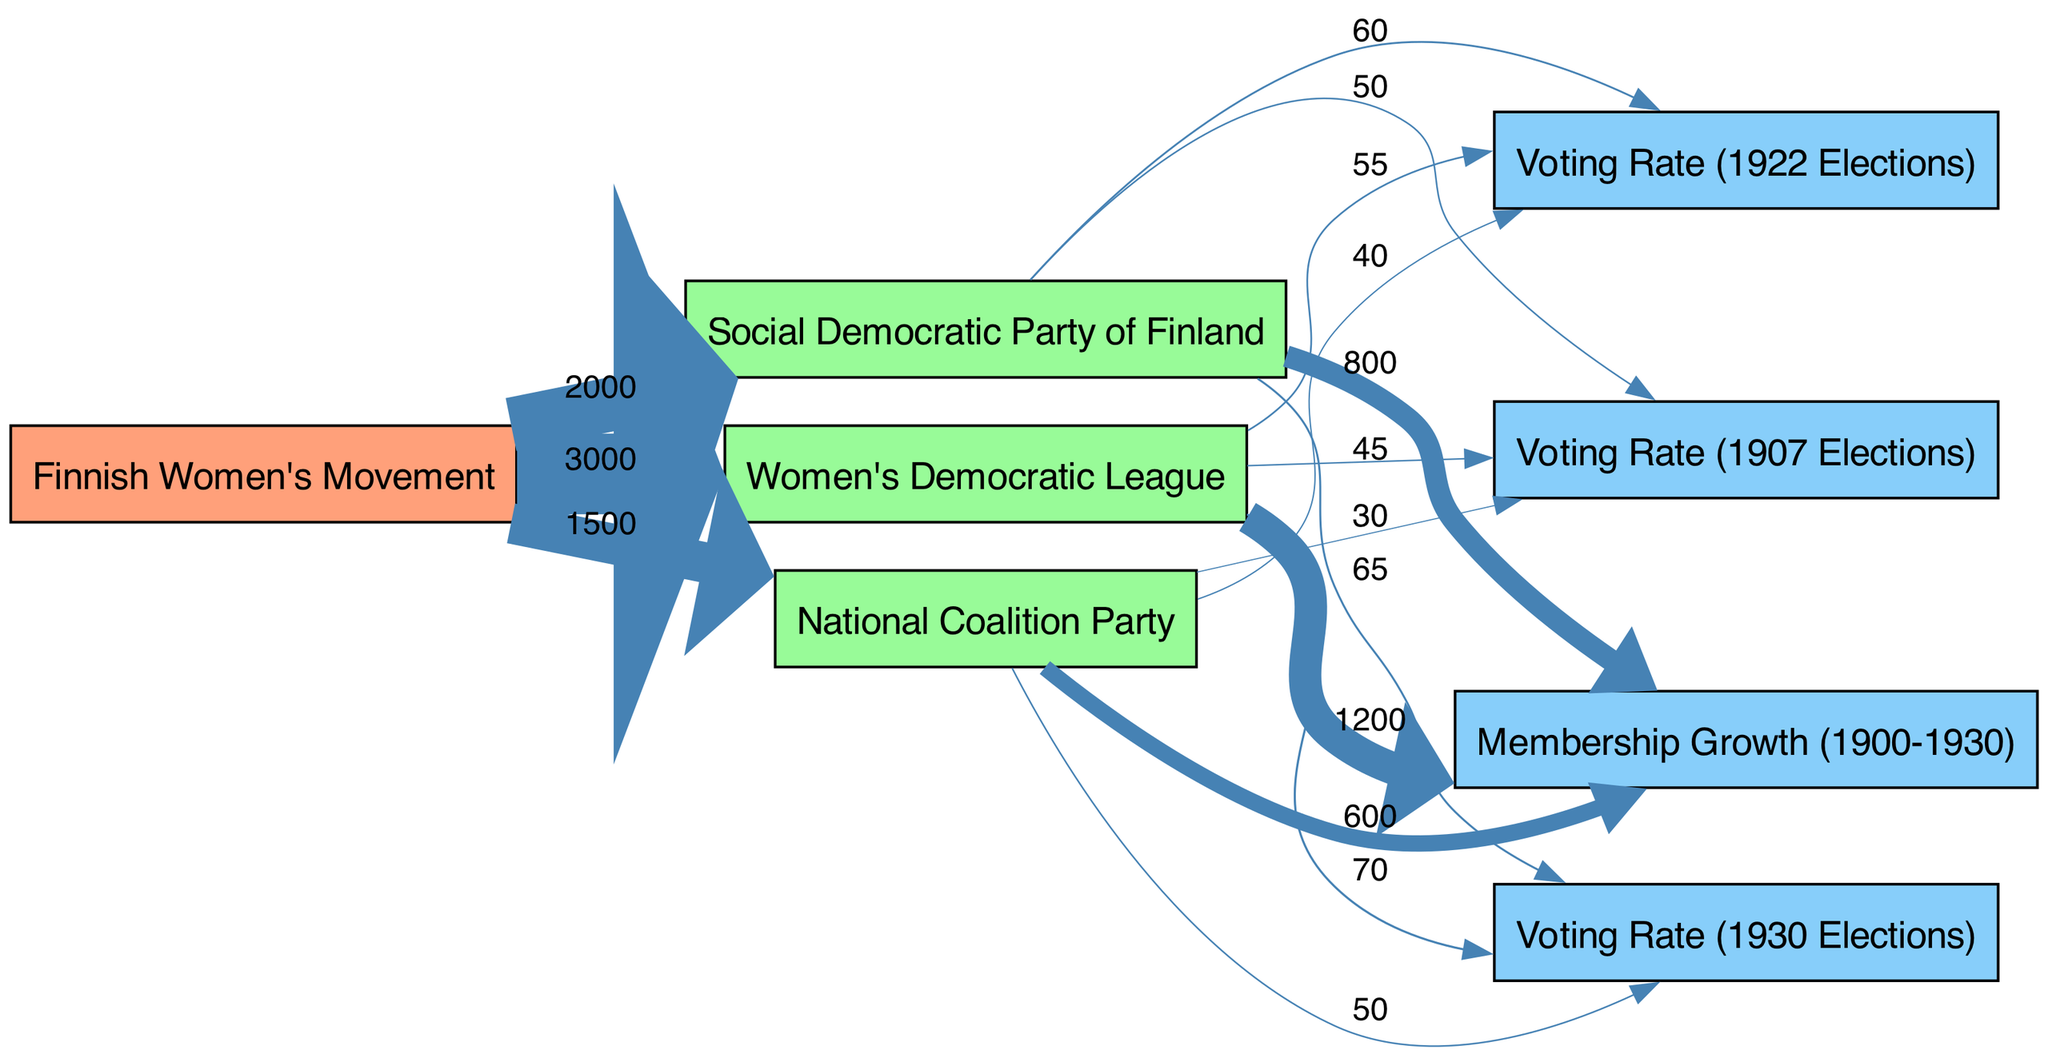What is the total membership flow to the Women's Democratic League? To find the total membership flow to the Women's Democratic League, we can observe the links stemming from "Finnish Women's Movement" to "Women's Democratic League", which shows a value of 3000 for member flow. This is the sum total for this party without further branching for membership.
Answer: 3000 What is the voting rate for the Social Democratic Party of Finland in the 1922 elections? In the section of the diagram that highlights voting trends, we find that the link from "Social Democratic Party of Finland" to "Voting Rate (1922 Elections)" specifies a value of 60. This directly provides the information requested about the voting rate in that election year for the Social Democratic Party.
Answer: 60 Which party had the lowest voting rate in the 1907 elections? By examining the voting rate values linked to each party in the 1907 elections, we note the following values: Women's Democratic League is 45, Social Democratic Party of Finland is 50, and National Coalition Party is 30. The lowest value here is that of the National Coalition Party, indicating it had the least voting rate in that year.
Answer: National Coalition Party What trends can be observed in membership growth from Women's Democratic League compared to the others? The membership growth for Women's Democratic League shows a value of 1200, Social Democratic Party of Finland has 800, and National Coalition Party has 600. Comparing these values, we can clearly see that the Women's Democratic League experienced the most membership growth from the Finnish Women's Movement over the given time period.
Answer: Women's Democratic League Which party saw the highest voting rate in the 1930 elections? In the section highlighting voting rates for the 1930 elections, we observe the linked values as follows: Women's Democratic League with 70, Social Democratic Party of Finland with 65, and National Coalition Party with 50. The highest value among these indicates that the Women's Democratic League attained the peak voting rate in that election.
Answer: Women's Democratic League What is the overall trend in voting rates from 1907 to 1930 for the Women's Democratic League? By looking at the voting rates for the Women's Democratic League across the years: 1907 elections at 45, 1922 elections at 55, and 1930 elections at 70, we can see a consistent increase over the years. This shows that the Women’s Democratic League improved its voting rate over time, demonstrating an upward trend in engagement and participation.
Answer: Increasing What is the total voting rate across all parties in the 1930 elections? Aggregating the voting rates for each party in the 1930 elections, we see Women's Democratic League at 70, Social Democratic Party at 65, and National Coalition Party at 50. Adding these values together gives us a total voting rate of 70 + 65 + 50 = 185 for the 1930 elections.
Answer: 185 Which party had the highest number of members overall? By looking directly at the membership links, we find the total values: Women's Democratic League at 3000, Social Democratic Party at 2000, and National Coalition Party at 1500. The Women's Democratic League clearly has the highest number of members overall, based on the aggregated flow from the Finnish Women's Movement.
Answer: Women's Democratic League 